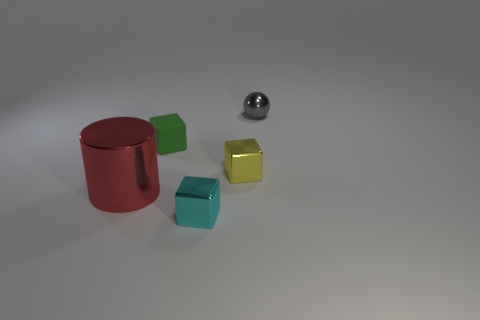Are there any other things that have the same size as the cylinder?
Offer a very short reply. No. What material is the green cube?
Offer a terse response. Rubber. How many small objects are to the right of the yellow thing?
Make the answer very short. 1. Is the number of objects behind the red metal thing less than the number of yellow cubes?
Ensure brevity in your answer.  No. The large metallic thing has what color?
Your answer should be compact. Red. There is another small metal object that is the same shape as the cyan thing; what color is it?
Make the answer very short. Yellow. How many tiny things are either green cubes or purple metallic cubes?
Your response must be concise. 1. What is the size of the block in front of the yellow metallic block?
Make the answer very short. Small. There is a tiny metal object behind the rubber object; what number of cubes are to the right of it?
Offer a very short reply. 0. What number of large things are made of the same material as the tiny green thing?
Provide a short and direct response. 0. 